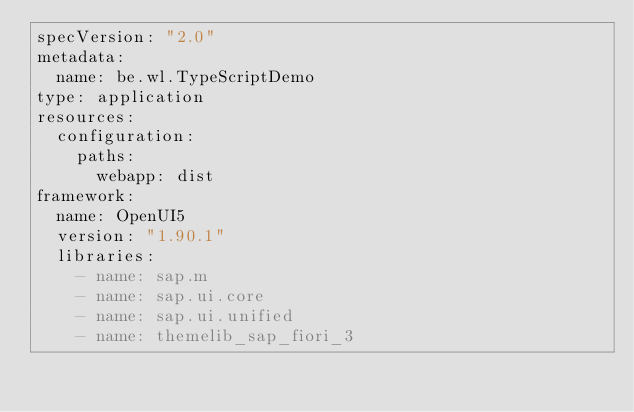<code> <loc_0><loc_0><loc_500><loc_500><_YAML_>specVersion: "2.0"
metadata:
  name: be.wl.TypeScriptDemo
type: application
resources:
  configuration:
    paths:
      webapp: dist
framework:
  name: OpenUI5
  version: "1.90.1"
  libraries:
    - name: sap.m
    - name: sap.ui.core
    - name: sap.ui.unified
    - name: themelib_sap_fiori_3</code> 